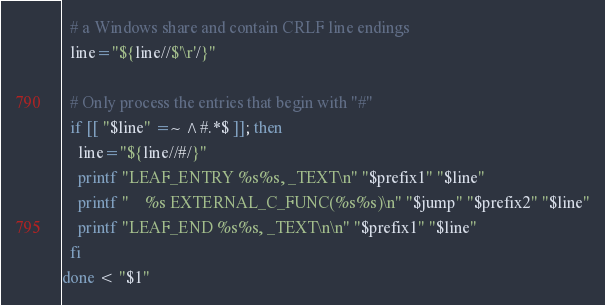Convert code to text. <code><loc_0><loc_0><loc_500><loc_500><_Bash_>  # a Windows share and contain CRLF line endings
  line="${line//$'\r'/}"

  # Only process the entries that begin with "#"
  if [[ "$line" =~ ^#.*$ ]]; then
    line="${line//#/}"
    printf "LEAF_ENTRY %s%s, _TEXT\n" "$prefix1" "$line"
    printf "    %s EXTERNAL_C_FUNC(%s%s)\n" "$jump" "$prefix2" "$line"
    printf "LEAF_END %s%s, _TEXT\n\n" "$prefix1" "$line"
  fi
done < "$1"
</code> 